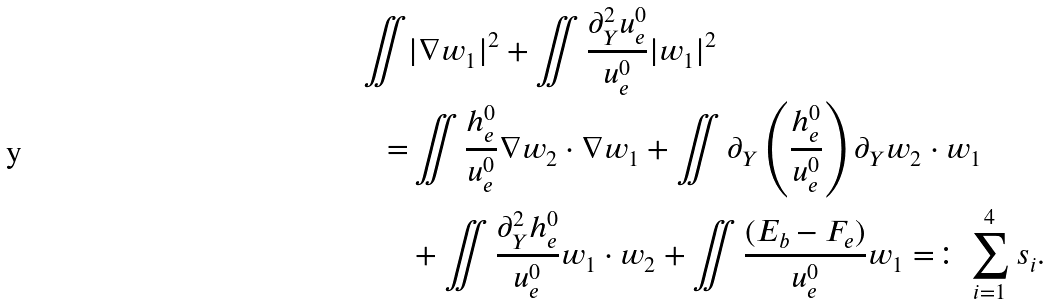Convert formula to latex. <formula><loc_0><loc_0><loc_500><loc_500>\iint & | \nabla w _ { 1 } | ^ { 2 } + \iint \frac { \partial _ { Y } ^ { 2 } u ^ { 0 } _ { e } } { u ^ { 0 } _ { e } } | w _ { 1 } | ^ { 2 } \\ = & \iint \frac { h ^ { 0 } _ { e } } { u ^ { 0 } _ { e } } \nabla w _ { 2 } \cdot \nabla w _ { 1 } + \iint \partial _ { Y } \left ( \frac { h ^ { 0 } _ { e } } { u ^ { 0 } _ { e } } \right ) \partial _ { Y } w _ { 2 } \cdot w _ { 1 } \\ & + \iint \frac { \partial _ { Y } ^ { 2 } h ^ { 0 } _ { e } } { u ^ { 0 } _ { e } } w _ { 1 } \cdot w _ { 2 } + \iint \frac { ( E _ { b } - F _ { e } ) } { u ^ { 0 } _ { e } } w _ { 1 } = \colon \sum _ { i = 1 } ^ { 4 } s _ { i } .</formula> 